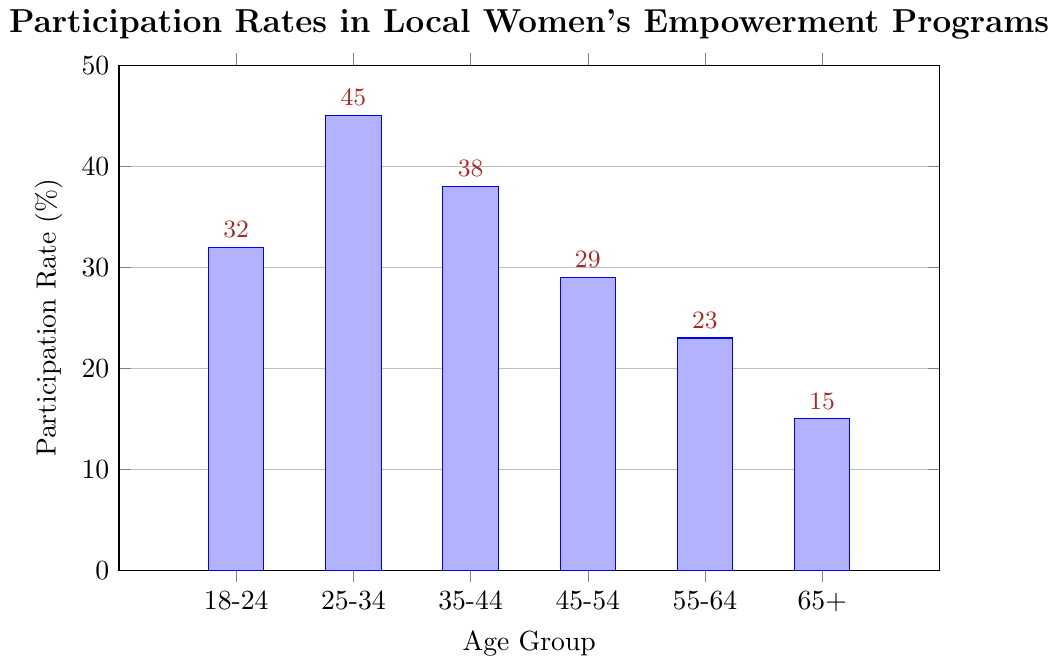Which age group has the highest participation rate? The figure shows the participation rates for different age groups. By inspecting the heights of the bars, the 25-34 age group has the highest participation rate.
Answer: 25-34 Which age group has the lowest participation rate? By checking the height of the bars, the 65+ age group has the shortest bar, indicating the lowest participation rate.
Answer: 65+ What is the difference in participation rate between the 25-34 age group and the 55-64 age group? The participation rate for the 25-34 group is 45%, and for the 55-64 group, it is 23%. The difference is calculated as 45 - 23 = 22%.
Answer: 22% What is the average participation rate across all age groups? Sum the participation rates of all age groups and divide by the number of groups: (32 + 45 + 38 + 29 + 23 + 15) / 6 = 182 / 6 = 30.33%.
Answer: 30.33% By how much does the participation rate for the 45-54 age group differ from the overall average participation rate? The participation rate for the 45-54 age group is 29%. The overall average participation rate is 30.33%. The difference is 30.33 - 29 = 1.33%.
Answer: 1.33% Which age group has a participation rate close to the overall average participation rate? The overall average participation rate is 30.33%. By comparing individual rates, the 45-54 age group has a rate of 29%, which is closest to the overall average.
Answer: 45-54 How many age groups have a participation rate higher than 30%? By checking the bars with rates higher than 30%: 18-24 (32%), 25-34 (45%), and 35-44 (38%), there are three such groups.
Answer: 3 Which two age groups have the largest difference in participation rates? Comparing individual rates, the 25-34 age group (45%) and the 65+ age group (15%) have the largest difference: 45 - 15 = 30%.
Answer: 25-34 and 65+ What is the combined participation rate for the age groups 55-64 and 65+? Adding the participation rates of these two groups: 23% and 15%. The combined rate is 23 + 15 = 38%.
Answer: 38% Between the age groups 35-44 and 45-54, which one has a higher participation rate and by how much? The participation rate for the 35-44 age group is 38%, and for the 45-54 age group, it is 29%. The difference is 38 - 29 = 9%.
Answer: 35-44, by 9% 